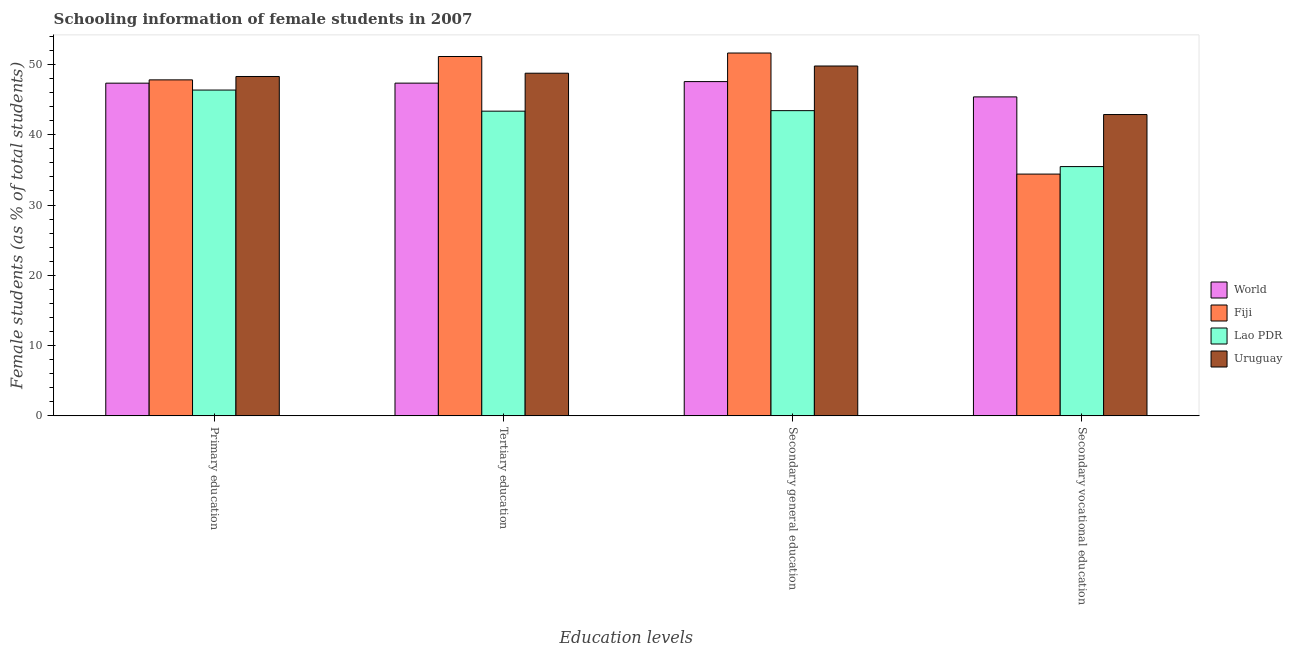How many different coloured bars are there?
Keep it short and to the point. 4. How many bars are there on the 2nd tick from the left?
Offer a very short reply. 4. What is the label of the 3rd group of bars from the left?
Provide a succinct answer. Secondary general education. What is the percentage of female students in tertiary education in Uruguay?
Provide a short and direct response. 48.76. Across all countries, what is the maximum percentage of female students in primary education?
Your answer should be very brief. 48.29. Across all countries, what is the minimum percentage of female students in primary education?
Provide a short and direct response. 46.36. In which country was the percentage of female students in tertiary education maximum?
Keep it short and to the point. Fiji. In which country was the percentage of female students in secondary education minimum?
Make the answer very short. Lao PDR. What is the total percentage of female students in primary education in the graph?
Your response must be concise. 189.81. What is the difference between the percentage of female students in primary education in Fiji and that in Lao PDR?
Give a very brief answer. 1.45. What is the difference between the percentage of female students in primary education in Uruguay and the percentage of female students in secondary education in Fiji?
Your response must be concise. -3.34. What is the average percentage of female students in primary education per country?
Ensure brevity in your answer.  47.45. What is the difference between the percentage of female students in primary education and percentage of female students in tertiary education in Uruguay?
Make the answer very short. -0.47. What is the ratio of the percentage of female students in secondary vocational education in World to that in Fiji?
Offer a terse response. 1.32. What is the difference between the highest and the second highest percentage of female students in secondary vocational education?
Keep it short and to the point. 2.51. What is the difference between the highest and the lowest percentage of female students in secondary vocational education?
Offer a very short reply. 10.98. In how many countries, is the percentage of female students in primary education greater than the average percentage of female students in primary education taken over all countries?
Provide a short and direct response. 2. Is the sum of the percentage of female students in secondary education in Lao PDR and Uruguay greater than the maximum percentage of female students in primary education across all countries?
Give a very brief answer. Yes. What does the 4th bar from the left in Secondary general education represents?
Your response must be concise. Uruguay. What does the 3rd bar from the right in Secondary general education represents?
Keep it short and to the point. Fiji. Is it the case that in every country, the sum of the percentage of female students in primary education and percentage of female students in tertiary education is greater than the percentage of female students in secondary education?
Offer a terse response. Yes. How many countries are there in the graph?
Keep it short and to the point. 4. What is the difference between two consecutive major ticks on the Y-axis?
Your response must be concise. 10. Are the values on the major ticks of Y-axis written in scientific E-notation?
Provide a succinct answer. No. Does the graph contain any zero values?
Provide a short and direct response. No. Does the graph contain grids?
Keep it short and to the point. No. How many legend labels are there?
Offer a very short reply. 4. What is the title of the graph?
Give a very brief answer. Schooling information of female students in 2007. Does "Congo (Democratic)" appear as one of the legend labels in the graph?
Your response must be concise. No. What is the label or title of the X-axis?
Your answer should be very brief. Education levels. What is the label or title of the Y-axis?
Give a very brief answer. Female students (as % of total students). What is the Female students (as % of total students) in World in Primary education?
Provide a short and direct response. 47.34. What is the Female students (as % of total students) in Fiji in Primary education?
Provide a short and direct response. 47.81. What is the Female students (as % of total students) of Lao PDR in Primary education?
Keep it short and to the point. 46.36. What is the Female students (as % of total students) in Uruguay in Primary education?
Give a very brief answer. 48.29. What is the Female students (as % of total students) in World in Tertiary education?
Provide a short and direct response. 47.35. What is the Female students (as % of total students) in Fiji in Tertiary education?
Give a very brief answer. 51.13. What is the Female students (as % of total students) in Lao PDR in Tertiary education?
Your answer should be compact. 43.36. What is the Female students (as % of total students) in Uruguay in Tertiary education?
Offer a terse response. 48.76. What is the Female students (as % of total students) in World in Secondary general education?
Give a very brief answer. 47.57. What is the Female students (as % of total students) in Fiji in Secondary general education?
Ensure brevity in your answer.  51.63. What is the Female students (as % of total students) of Lao PDR in Secondary general education?
Ensure brevity in your answer.  43.43. What is the Female students (as % of total students) of Uruguay in Secondary general education?
Your answer should be very brief. 49.78. What is the Female students (as % of total students) of World in Secondary vocational education?
Your response must be concise. 45.39. What is the Female students (as % of total students) in Fiji in Secondary vocational education?
Make the answer very short. 34.4. What is the Female students (as % of total students) of Lao PDR in Secondary vocational education?
Your answer should be compact. 35.47. What is the Female students (as % of total students) of Uruguay in Secondary vocational education?
Offer a very short reply. 42.88. Across all Education levels, what is the maximum Female students (as % of total students) in World?
Your response must be concise. 47.57. Across all Education levels, what is the maximum Female students (as % of total students) in Fiji?
Make the answer very short. 51.63. Across all Education levels, what is the maximum Female students (as % of total students) in Lao PDR?
Your answer should be compact. 46.36. Across all Education levels, what is the maximum Female students (as % of total students) of Uruguay?
Give a very brief answer. 49.78. Across all Education levels, what is the minimum Female students (as % of total students) of World?
Your response must be concise. 45.39. Across all Education levels, what is the minimum Female students (as % of total students) of Fiji?
Keep it short and to the point. 34.4. Across all Education levels, what is the minimum Female students (as % of total students) of Lao PDR?
Keep it short and to the point. 35.47. Across all Education levels, what is the minimum Female students (as % of total students) of Uruguay?
Keep it short and to the point. 42.88. What is the total Female students (as % of total students) in World in the graph?
Your answer should be compact. 187.64. What is the total Female students (as % of total students) in Fiji in the graph?
Offer a very short reply. 184.98. What is the total Female students (as % of total students) of Lao PDR in the graph?
Keep it short and to the point. 168.62. What is the total Female students (as % of total students) of Uruguay in the graph?
Offer a terse response. 189.71. What is the difference between the Female students (as % of total students) in World in Primary education and that in Tertiary education?
Make the answer very short. -0.01. What is the difference between the Female students (as % of total students) of Fiji in Primary education and that in Tertiary education?
Your response must be concise. -3.32. What is the difference between the Female students (as % of total students) of Lao PDR in Primary education and that in Tertiary education?
Your answer should be very brief. 3. What is the difference between the Female students (as % of total students) of Uruguay in Primary education and that in Tertiary education?
Your answer should be very brief. -0.47. What is the difference between the Female students (as % of total students) in World in Primary education and that in Secondary general education?
Offer a very short reply. -0.22. What is the difference between the Female students (as % of total students) of Fiji in Primary education and that in Secondary general education?
Offer a terse response. -3.82. What is the difference between the Female students (as % of total students) of Lao PDR in Primary education and that in Secondary general education?
Provide a succinct answer. 2.93. What is the difference between the Female students (as % of total students) of Uruguay in Primary education and that in Secondary general education?
Give a very brief answer. -1.49. What is the difference between the Female students (as % of total students) of World in Primary education and that in Secondary vocational education?
Provide a short and direct response. 1.95. What is the difference between the Female students (as % of total students) of Fiji in Primary education and that in Secondary vocational education?
Keep it short and to the point. 13.41. What is the difference between the Female students (as % of total students) of Lao PDR in Primary education and that in Secondary vocational education?
Provide a short and direct response. 10.89. What is the difference between the Female students (as % of total students) of Uruguay in Primary education and that in Secondary vocational education?
Make the answer very short. 5.42. What is the difference between the Female students (as % of total students) of World in Tertiary education and that in Secondary general education?
Offer a terse response. -0.22. What is the difference between the Female students (as % of total students) of Fiji in Tertiary education and that in Secondary general education?
Your answer should be very brief. -0.5. What is the difference between the Female students (as % of total students) in Lao PDR in Tertiary education and that in Secondary general education?
Ensure brevity in your answer.  -0.07. What is the difference between the Female students (as % of total students) in Uruguay in Tertiary education and that in Secondary general education?
Offer a terse response. -1.03. What is the difference between the Female students (as % of total students) in World in Tertiary education and that in Secondary vocational education?
Give a very brief answer. 1.96. What is the difference between the Female students (as % of total students) of Fiji in Tertiary education and that in Secondary vocational education?
Your answer should be compact. 16.73. What is the difference between the Female students (as % of total students) of Lao PDR in Tertiary education and that in Secondary vocational education?
Offer a very short reply. 7.89. What is the difference between the Female students (as % of total students) of Uruguay in Tertiary education and that in Secondary vocational education?
Offer a terse response. 5.88. What is the difference between the Female students (as % of total students) in World in Secondary general education and that in Secondary vocational education?
Ensure brevity in your answer.  2.18. What is the difference between the Female students (as % of total students) of Fiji in Secondary general education and that in Secondary vocational education?
Your answer should be very brief. 17.23. What is the difference between the Female students (as % of total students) of Lao PDR in Secondary general education and that in Secondary vocational education?
Your response must be concise. 7.96. What is the difference between the Female students (as % of total students) in Uruguay in Secondary general education and that in Secondary vocational education?
Offer a terse response. 6.91. What is the difference between the Female students (as % of total students) in World in Primary education and the Female students (as % of total students) in Fiji in Tertiary education?
Offer a terse response. -3.79. What is the difference between the Female students (as % of total students) of World in Primary education and the Female students (as % of total students) of Lao PDR in Tertiary education?
Your answer should be very brief. 3.98. What is the difference between the Female students (as % of total students) of World in Primary education and the Female students (as % of total students) of Uruguay in Tertiary education?
Give a very brief answer. -1.42. What is the difference between the Female students (as % of total students) of Fiji in Primary education and the Female students (as % of total students) of Lao PDR in Tertiary education?
Offer a very short reply. 4.45. What is the difference between the Female students (as % of total students) in Fiji in Primary education and the Female students (as % of total students) in Uruguay in Tertiary education?
Your answer should be very brief. -0.95. What is the difference between the Female students (as % of total students) in Lao PDR in Primary education and the Female students (as % of total students) in Uruguay in Tertiary education?
Provide a short and direct response. -2.4. What is the difference between the Female students (as % of total students) in World in Primary education and the Female students (as % of total students) in Fiji in Secondary general education?
Your response must be concise. -4.29. What is the difference between the Female students (as % of total students) of World in Primary education and the Female students (as % of total students) of Lao PDR in Secondary general education?
Make the answer very short. 3.91. What is the difference between the Female students (as % of total students) in World in Primary education and the Female students (as % of total students) in Uruguay in Secondary general education?
Provide a short and direct response. -2.44. What is the difference between the Female students (as % of total students) in Fiji in Primary education and the Female students (as % of total students) in Lao PDR in Secondary general education?
Provide a short and direct response. 4.38. What is the difference between the Female students (as % of total students) in Fiji in Primary education and the Female students (as % of total students) in Uruguay in Secondary general education?
Your answer should be very brief. -1.97. What is the difference between the Female students (as % of total students) of Lao PDR in Primary education and the Female students (as % of total students) of Uruguay in Secondary general education?
Provide a short and direct response. -3.42. What is the difference between the Female students (as % of total students) of World in Primary education and the Female students (as % of total students) of Fiji in Secondary vocational education?
Make the answer very short. 12.94. What is the difference between the Female students (as % of total students) of World in Primary education and the Female students (as % of total students) of Lao PDR in Secondary vocational education?
Your answer should be compact. 11.87. What is the difference between the Female students (as % of total students) in World in Primary education and the Female students (as % of total students) in Uruguay in Secondary vocational education?
Provide a short and direct response. 4.46. What is the difference between the Female students (as % of total students) in Fiji in Primary education and the Female students (as % of total students) in Lao PDR in Secondary vocational education?
Your answer should be compact. 12.34. What is the difference between the Female students (as % of total students) of Fiji in Primary education and the Female students (as % of total students) of Uruguay in Secondary vocational education?
Your answer should be compact. 4.94. What is the difference between the Female students (as % of total students) of Lao PDR in Primary education and the Female students (as % of total students) of Uruguay in Secondary vocational education?
Ensure brevity in your answer.  3.48. What is the difference between the Female students (as % of total students) of World in Tertiary education and the Female students (as % of total students) of Fiji in Secondary general education?
Your response must be concise. -4.29. What is the difference between the Female students (as % of total students) in World in Tertiary education and the Female students (as % of total students) in Lao PDR in Secondary general education?
Your response must be concise. 3.92. What is the difference between the Female students (as % of total students) of World in Tertiary education and the Female students (as % of total students) of Uruguay in Secondary general education?
Keep it short and to the point. -2.44. What is the difference between the Female students (as % of total students) in Fiji in Tertiary education and the Female students (as % of total students) in Lao PDR in Secondary general education?
Ensure brevity in your answer.  7.7. What is the difference between the Female students (as % of total students) in Fiji in Tertiary education and the Female students (as % of total students) in Uruguay in Secondary general education?
Your answer should be very brief. 1.35. What is the difference between the Female students (as % of total students) in Lao PDR in Tertiary education and the Female students (as % of total students) in Uruguay in Secondary general education?
Provide a succinct answer. -6.43. What is the difference between the Female students (as % of total students) of World in Tertiary education and the Female students (as % of total students) of Fiji in Secondary vocational education?
Give a very brief answer. 12.94. What is the difference between the Female students (as % of total students) in World in Tertiary education and the Female students (as % of total students) in Lao PDR in Secondary vocational education?
Give a very brief answer. 11.87. What is the difference between the Female students (as % of total students) of World in Tertiary education and the Female students (as % of total students) of Uruguay in Secondary vocational education?
Keep it short and to the point. 4.47. What is the difference between the Female students (as % of total students) in Fiji in Tertiary education and the Female students (as % of total students) in Lao PDR in Secondary vocational education?
Offer a terse response. 15.66. What is the difference between the Female students (as % of total students) of Fiji in Tertiary education and the Female students (as % of total students) of Uruguay in Secondary vocational education?
Provide a succinct answer. 8.26. What is the difference between the Female students (as % of total students) of Lao PDR in Tertiary education and the Female students (as % of total students) of Uruguay in Secondary vocational education?
Your response must be concise. 0.48. What is the difference between the Female students (as % of total students) of World in Secondary general education and the Female students (as % of total students) of Fiji in Secondary vocational education?
Give a very brief answer. 13.16. What is the difference between the Female students (as % of total students) of World in Secondary general education and the Female students (as % of total students) of Lao PDR in Secondary vocational education?
Keep it short and to the point. 12.09. What is the difference between the Female students (as % of total students) of World in Secondary general education and the Female students (as % of total students) of Uruguay in Secondary vocational education?
Your response must be concise. 4.69. What is the difference between the Female students (as % of total students) of Fiji in Secondary general education and the Female students (as % of total students) of Lao PDR in Secondary vocational education?
Provide a succinct answer. 16.16. What is the difference between the Female students (as % of total students) in Fiji in Secondary general education and the Female students (as % of total students) in Uruguay in Secondary vocational education?
Offer a very short reply. 8.75. What is the difference between the Female students (as % of total students) of Lao PDR in Secondary general education and the Female students (as % of total students) of Uruguay in Secondary vocational education?
Your answer should be very brief. 0.55. What is the average Female students (as % of total students) of World per Education levels?
Ensure brevity in your answer.  46.91. What is the average Female students (as % of total students) of Fiji per Education levels?
Ensure brevity in your answer.  46.25. What is the average Female students (as % of total students) of Lao PDR per Education levels?
Make the answer very short. 42.16. What is the average Female students (as % of total students) in Uruguay per Education levels?
Keep it short and to the point. 47.43. What is the difference between the Female students (as % of total students) in World and Female students (as % of total students) in Fiji in Primary education?
Offer a very short reply. -0.47. What is the difference between the Female students (as % of total students) of World and Female students (as % of total students) of Lao PDR in Primary education?
Provide a short and direct response. 0.98. What is the difference between the Female students (as % of total students) of World and Female students (as % of total students) of Uruguay in Primary education?
Provide a succinct answer. -0.95. What is the difference between the Female students (as % of total students) in Fiji and Female students (as % of total students) in Lao PDR in Primary education?
Make the answer very short. 1.45. What is the difference between the Female students (as % of total students) of Fiji and Female students (as % of total students) of Uruguay in Primary education?
Keep it short and to the point. -0.48. What is the difference between the Female students (as % of total students) of Lao PDR and Female students (as % of total students) of Uruguay in Primary education?
Keep it short and to the point. -1.93. What is the difference between the Female students (as % of total students) in World and Female students (as % of total students) in Fiji in Tertiary education?
Your response must be concise. -3.79. What is the difference between the Female students (as % of total students) in World and Female students (as % of total students) in Lao PDR in Tertiary education?
Ensure brevity in your answer.  3.99. What is the difference between the Female students (as % of total students) of World and Female students (as % of total students) of Uruguay in Tertiary education?
Offer a very short reply. -1.41. What is the difference between the Female students (as % of total students) of Fiji and Female students (as % of total students) of Lao PDR in Tertiary education?
Offer a very short reply. 7.78. What is the difference between the Female students (as % of total students) in Fiji and Female students (as % of total students) in Uruguay in Tertiary education?
Provide a short and direct response. 2.38. What is the difference between the Female students (as % of total students) in Lao PDR and Female students (as % of total students) in Uruguay in Tertiary education?
Ensure brevity in your answer.  -5.4. What is the difference between the Female students (as % of total students) in World and Female students (as % of total students) in Fiji in Secondary general education?
Ensure brevity in your answer.  -4.07. What is the difference between the Female students (as % of total students) of World and Female students (as % of total students) of Lao PDR in Secondary general education?
Ensure brevity in your answer.  4.13. What is the difference between the Female students (as % of total students) of World and Female students (as % of total students) of Uruguay in Secondary general education?
Provide a succinct answer. -2.22. What is the difference between the Female students (as % of total students) of Fiji and Female students (as % of total students) of Lao PDR in Secondary general education?
Your answer should be very brief. 8.2. What is the difference between the Female students (as % of total students) of Fiji and Female students (as % of total students) of Uruguay in Secondary general education?
Offer a terse response. 1.85. What is the difference between the Female students (as % of total students) in Lao PDR and Female students (as % of total students) in Uruguay in Secondary general education?
Make the answer very short. -6.35. What is the difference between the Female students (as % of total students) in World and Female students (as % of total students) in Fiji in Secondary vocational education?
Your response must be concise. 10.98. What is the difference between the Female students (as % of total students) in World and Female students (as % of total students) in Lao PDR in Secondary vocational education?
Your answer should be compact. 9.92. What is the difference between the Female students (as % of total students) of World and Female students (as % of total students) of Uruguay in Secondary vocational education?
Make the answer very short. 2.51. What is the difference between the Female students (as % of total students) in Fiji and Female students (as % of total students) in Lao PDR in Secondary vocational education?
Offer a very short reply. -1.07. What is the difference between the Female students (as % of total students) in Fiji and Female students (as % of total students) in Uruguay in Secondary vocational education?
Provide a short and direct response. -8.47. What is the difference between the Female students (as % of total students) of Lao PDR and Female students (as % of total students) of Uruguay in Secondary vocational education?
Ensure brevity in your answer.  -7.41. What is the ratio of the Female students (as % of total students) in World in Primary education to that in Tertiary education?
Your answer should be very brief. 1. What is the ratio of the Female students (as % of total students) of Fiji in Primary education to that in Tertiary education?
Make the answer very short. 0.94. What is the ratio of the Female students (as % of total students) in Lao PDR in Primary education to that in Tertiary education?
Give a very brief answer. 1.07. What is the ratio of the Female students (as % of total students) of World in Primary education to that in Secondary general education?
Give a very brief answer. 1. What is the ratio of the Female students (as % of total students) of Fiji in Primary education to that in Secondary general education?
Keep it short and to the point. 0.93. What is the ratio of the Female students (as % of total students) in Lao PDR in Primary education to that in Secondary general education?
Make the answer very short. 1.07. What is the ratio of the Female students (as % of total students) of World in Primary education to that in Secondary vocational education?
Offer a terse response. 1.04. What is the ratio of the Female students (as % of total students) in Fiji in Primary education to that in Secondary vocational education?
Provide a succinct answer. 1.39. What is the ratio of the Female students (as % of total students) in Lao PDR in Primary education to that in Secondary vocational education?
Make the answer very short. 1.31. What is the ratio of the Female students (as % of total students) in Uruguay in Primary education to that in Secondary vocational education?
Offer a terse response. 1.13. What is the ratio of the Female students (as % of total students) of Uruguay in Tertiary education to that in Secondary general education?
Make the answer very short. 0.98. What is the ratio of the Female students (as % of total students) of World in Tertiary education to that in Secondary vocational education?
Your response must be concise. 1.04. What is the ratio of the Female students (as % of total students) of Fiji in Tertiary education to that in Secondary vocational education?
Ensure brevity in your answer.  1.49. What is the ratio of the Female students (as % of total students) in Lao PDR in Tertiary education to that in Secondary vocational education?
Provide a short and direct response. 1.22. What is the ratio of the Female students (as % of total students) in Uruguay in Tertiary education to that in Secondary vocational education?
Provide a short and direct response. 1.14. What is the ratio of the Female students (as % of total students) in World in Secondary general education to that in Secondary vocational education?
Provide a short and direct response. 1.05. What is the ratio of the Female students (as % of total students) of Fiji in Secondary general education to that in Secondary vocational education?
Ensure brevity in your answer.  1.5. What is the ratio of the Female students (as % of total students) of Lao PDR in Secondary general education to that in Secondary vocational education?
Keep it short and to the point. 1.22. What is the ratio of the Female students (as % of total students) of Uruguay in Secondary general education to that in Secondary vocational education?
Give a very brief answer. 1.16. What is the difference between the highest and the second highest Female students (as % of total students) in World?
Give a very brief answer. 0.22. What is the difference between the highest and the second highest Female students (as % of total students) of Fiji?
Offer a terse response. 0.5. What is the difference between the highest and the second highest Female students (as % of total students) in Lao PDR?
Make the answer very short. 2.93. What is the difference between the highest and the second highest Female students (as % of total students) in Uruguay?
Provide a succinct answer. 1.03. What is the difference between the highest and the lowest Female students (as % of total students) in World?
Provide a succinct answer. 2.18. What is the difference between the highest and the lowest Female students (as % of total students) of Fiji?
Keep it short and to the point. 17.23. What is the difference between the highest and the lowest Female students (as % of total students) in Lao PDR?
Offer a terse response. 10.89. What is the difference between the highest and the lowest Female students (as % of total students) in Uruguay?
Provide a succinct answer. 6.91. 